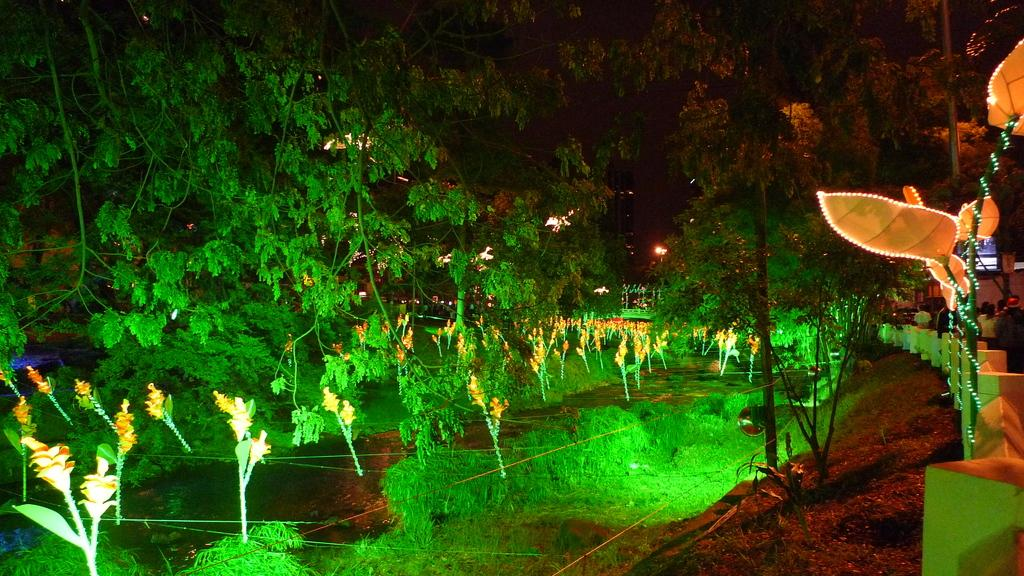What type of natural elements can be seen in the image? There are trees in the image. What man-made structures are present in the image? There are poles and lights in the image. Where is the fencing located in the image? The fencing is in the bottom right side of the image. What are the people behind the fencing doing? There are people standing and walking behind the fencing. What type of scarf is being worn by the tree in the image? There are no scarves present in the image, as trees do not wear clothing. What type of office can be seen in the background of the image? There is no office visible in the image; it features trees, poles, lights, fencing, and people. 